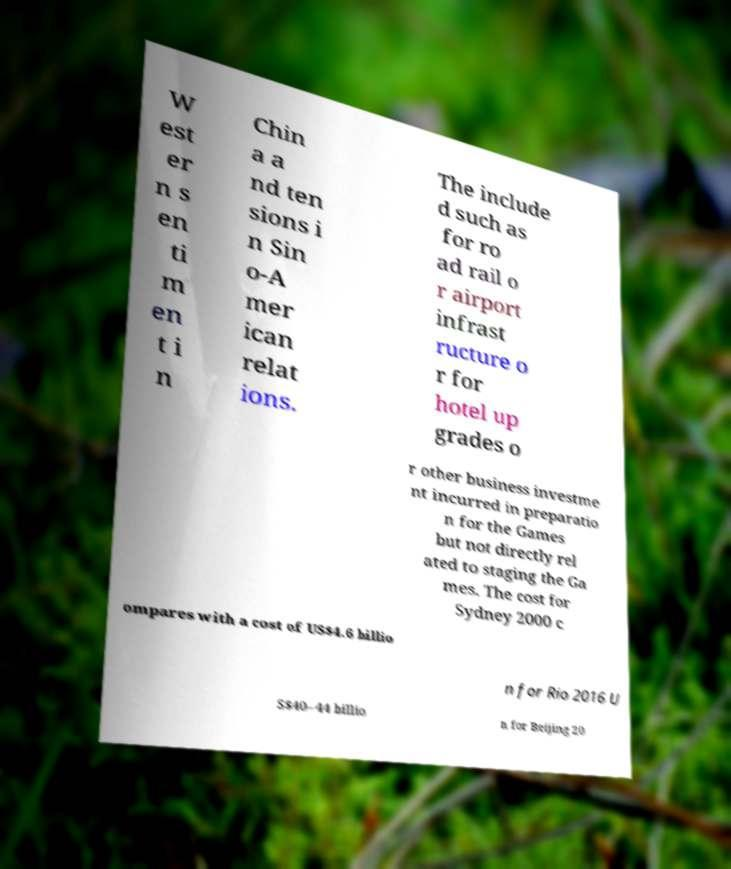Can you accurately transcribe the text from the provided image for me? W est er n s en ti m en t i n Chin a a nd ten sions i n Sin o-A mer ican relat ions. The include d such as for ro ad rail o r airport infrast ructure o r for hotel up grades o r other business investme nt incurred in preparatio n for the Games but not directly rel ated to staging the Ga mes. The cost for Sydney 2000 c ompares with a cost of US$4.6 billio n for Rio 2016 U S$40–44 billio n for Beijing 20 